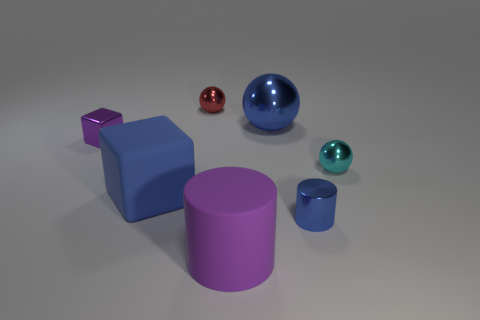The cyan object is what shape?
Ensure brevity in your answer.  Sphere. How many large blue objects have the same material as the tiny purple block?
Keep it short and to the point. 1. There is a small cube that is the same material as the large blue sphere; what color is it?
Provide a succinct answer. Purple. There is a blue shiny thing in front of the matte block; is its size the same as the small purple cube?
Ensure brevity in your answer.  Yes. There is another tiny metallic object that is the same shape as the cyan shiny thing; what is its color?
Keep it short and to the point. Red. There is a matte object that is to the right of the small ball that is to the left of the large shiny object on the right side of the small block; what is its shape?
Give a very brief answer. Cylinder. Do the tiny blue object and the purple matte thing have the same shape?
Keep it short and to the point. Yes. There is a tiny thing on the left side of the small shiny sphere behind the purple cube; what shape is it?
Offer a terse response. Cube. Are there any tiny cyan metal cubes?
Offer a terse response. No. How many large blue matte objects are behind the block to the left of the blue thing on the left side of the red shiny thing?
Make the answer very short. 0. 